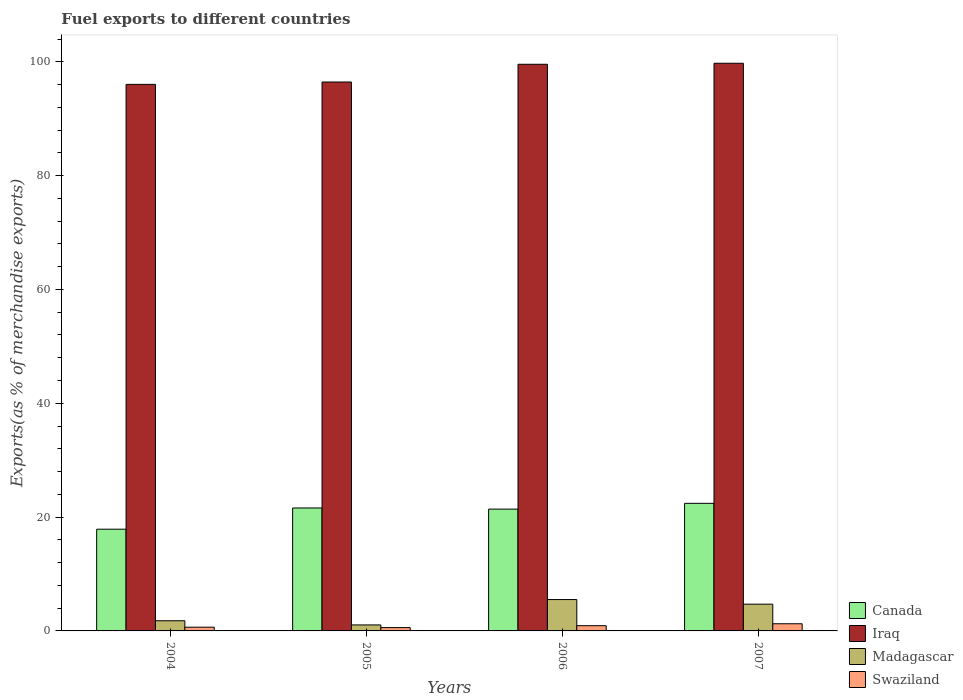How many different coloured bars are there?
Your answer should be very brief. 4. How many groups of bars are there?
Your response must be concise. 4. Are the number of bars per tick equal to the number of legend labels?
Give a very brief answer. Yes. What is the label of the 2nd group of bars from the left?
Offer a very short reply. 2005. In how many cases, is the number of bars for a given year not equal to the number of legend labels?
Your response must be concise. 0. What is the percentage of exports to different countries in Swaziland in 2005?
Provide a short and direct response. 0.58. Across all years, what is the maximum percentage of exports to different countries in Madagascar?
Your answer should be compact. 5.51. Across all years, what is the minimum percentage of exports to different countries in Iraq?
Your response must be concise. 96.03. What is the total percentage of exports to different countries in Iraq in the graph?
Ensure brevity in your answer.  391.78. What is the difference between the percentage of exports to different countries in Canada in 2004 and that in 2005?
Give a very brief answer. -3.73. What is the difference between the percentage of exports to different countries in Iraq in 2007 and the percentage of exports to different countries in Swaziland in 2006?
Give a very brief answer. 98.82. What is the average percentage of exports to different countries in Canada per year?
Your answer should be very brief. 20.82. In the year 2007, what is the difference between the percentage of exports to different countries in Iraq and percentage of exports to different countries in Canada?
Give a very brief answer. 77.32. What is the ratio of the percentage of exports to different countries in Iraq in 2004 to that in 2006?
Offer a very short reply. 0.96. Is the difference between the percentage of exports to different countries in Iraq in 2005 and 2006 greater than the difference between the percentage of exports to different countries in Canada in 2005 and 2006?
Give a very brief answer. No. What is the difference between the highest and the second highest percentage of exports to different countries in Madagascar?
Keep it short and to the point. 0.81. What is the difference between the highest and the lowest percentage of exports to different countries in Canada?
Offer a terse response. 4.54. In how many years, is the percentage of exports to different countries in Canada greater than the average percentage of exports to different countries in Canada taken over all years?
Offer a very short reply. 3. Is it the case that in every year, the sum of the percentage of exports to different countries in Madagascar and percentage of exports to different countries in Swaziland is greater than the sum of percentage of exports to different countries in Canada and percentage of exports to different countries in Iraq?
Give a very brief answer. No. What does the 1st bar from the left in 2006 represents?
Your answer should be very brief. Canada. What does the 4th bar from the right in 2004 represents?
Give a very brief answer. Canada. How many bars are there?
Keep it short and to the point. 16. Are all the bars in the graph horizontal?
Your answer should be compact. No. How many years are there in the graph?
Offer a terse response. 4. What is the difference between two consecutive major ticks on the Y-axis?
Keep it short and to the point. 20. Does the graph contain any zero values?
Offer a very short reply. No. Where does the legend appear in the graph?
Offer a terse response. Bottom right. How are the legend labels stacked?
Your answer should be compact. Vertical. What is the title of the graph?
Your answer should be very brief. Fuel exports to different countries. What is the label or title of the X-axis?
Provide a short and direct response. Years. What is the label or title of the Y-axis?
Ensure brevity in your answer.  Exports(as % of merchandise exports). What is the Exports(as % of merchandise exports) of Canada in 2004?
Offer a terse response. 17.87. What is the Exports(as % of merchandise exports) in Iraq in 2004?
Provide a succinct answer. 96.03. What is the Exports(as % of merchandise exports) of Madagascar in 2004?
Your response must be concise. 1.79. What is the Exports(as % of merchandise exports) of Swaziland in 2004?
Offer a terse response. 0.65. What is the Exports(as % of merchandise exports) of Canada in 2005?
Provide a short and direct response. 21.6. What is the Exports(as % of merchandise exports) in Iraq in 2005?
Provide a succinct answer. 96.45. What is the Exports(as % of merchandise exports) in Madagascar in 2005?
Offer a very short reply. 1.05. What is the Exports(as % of merchandise exports) of Swaziland in 2005?
Offer a terse response. 0.58. What is the Exports(as % of merchandise exports) of Canada in 2006?
Your answer should be very brief. 21.4. What is the Exports(as % of merchandise exports) of Iraq in 2006?
Make the answer very short. 99.56. What is the Exports(as % of merchandise exports) in Madagascar in 2006?
Provide a short and direct response. 5.51. What is the Exports(as % of merchandise exports) in Swaziland in 2006?
Offer a very short reply. 0.92. What is the Exports(as % of merchandise exports) in Canada in 2007?
Your response must be concise. 22.42. What is the Exports(as % of merchandise exports) in Iraq in 2007?
Your response must be concise. 99.74. What is the Exports(as % of merchandise exports) of Madagascar in 2007?
Keep it short and to the point. 4.7. What is the Exports(as % of merchandise exports) in Swaziland in 2007?
Ensure brevity in your answer.  1.26. Across all years, what is the maximum Exports(as % of merchandise exports) of Canada?
Your answer should be compact. 22.42. Across all years, what is the maximum Exports(as % of merchandise exports) in Iraq?
Ensure brevity in your answer.  99.74. Across all years, what is the maximum Exports(as % of merchandise exports) in Madagascar?
Offer a very short reply. 5.51. Across all years, what is the maximum Exports(as % of merchandise exports) in Swaziland?
Your response must be concise. 1.26. Across all years, what is the minimum Exports(as % of merchandise exports) in Canada?
Keep it short and to the point. 17.87. Across all years, what is the minimum Exports(as % of merchandise exports) of Iraq?
Provide a short and direct response. 96.03. Across all years, what is the minimum Exports(as % of merchandise exports) of Madagascar?
Your response must be concise. 1.05. Across all years, what is the minimum Exports(as % of merchandise exports) of Swaziland?
Keep it short and to the point. 0.58. What is the total Exports(as % of merchandise exports) of Canada in the graph?
Your response must be concise. 83.29. What is the total Exports(as % of merchandise exports) of Iraq in the graph?
Make the answer very short. 391.78. What is the total Exports(as % of merchandise exports) in Madagascar in the graph?
Ensure brevity in your answer.  13.05. What is the total Exports(as % of merchandise exports) of Swaziland in the graph?
Make the answer very short. 3.41. What is the difference between the Exports(as % of merchandise exports) in Canada in 2004 and that in 2005?
Give a very brief answer. -3.73. What is the difference between the Exports(as % of merchandise exports) of Iraq in 2004 and that in 2005?
Keep it short and to the point. -0.41. What is the difference between the Exports(as % of merchandise exports) of Madagascar in 2004 and that in 2005?
Provide a succinct answer. 0.73. What is the difference between the Exports(as % of merchandise exports) of Swaziland in 2004 and that in 2005?
Provide a short and direct response. 0.07. What is the difference between the Exports(as % of merchandise exports) of Canada in 2004 and that in 2006?
Ensure brevity in your answer.  -3.53. What is the difference between the Exports(as % of merchandise exports) in Iraq in 2004 and that in 2006?
Make the answer very short. -3.53. What is the difference between the Exports(as % of merchandise exports) of Madagascar in 2004 and that in 2006?
Keep it short and to the point. -3.72. What is the difference between the Exports(as % of merchandise exports) in Swaziland in 2004 and that in 2006?
Provide a short and direct response. -0.27. What is the difference between the Exports(as % of merchandise exports) of Canada in 2004 and that in 2007?
Your response must be concise. -4.54. What is the difference between the Exports(as % of merchandise exports) of Iraq in 2004 and that in 2007?
Make the answer very short. -3.71. What is the difference between the Exports(as % of merchandise exports) of Madagascar in 2004 and that in 2007?
Offer a terse response. -2.92. What is the difference between the Exports(as % of merchandise exports) of Swaziland in 2004 and that in 2007?
Offer a very short reply. -0.6. What is the difference between the Exports(as % of merchandise exports) of Canada in 2005 and that in 2006?
Provide a short and direct response. 0.2. What is the difference between the Exports(as % of merchandise exports) in Iraq in 2005 and that in 2006?
Offer a terse response. -3.12. What is the difference between the Exports(as % of merchandise exports) in Madagascar in 2005 and that in 2006?
Ensure brevity in your answer.  -4.46. What is the difference between the Exports(as % of merchandise exports) in Swaziland in 2005 and that in 2006?
Make the answer very short. -0.34. What is the difference between the Exports(as % of merchandise exports) of Canada in 2005 and that in 2007?
Provide a succinct answer. -0.82. What is the difference between the Exports(as % of merchandise exports) in Iraq in 2005 and that in 2007?
Provide a succinct answer. -3.29. What is the difference between the Exports(as % of merchandise exports) of Madagascar in 2005 and that in 2007?
Your answer should be very brief. -3.65. What is the difference between the Exports(as % of merchandise exports) of Swaziland in 2005 and that in 2007?
Ensure brevity in your answer.  -0.68. What is the difference between the Exports(as % of merchandise exports) in Canada in 2006 and that in 2007?
Provide a succinct answer. -1.02. What is the difference between the Exports(as % of merchandise exports) of Iraq in 2006 and that in 2007?
Offer a very short reply. -0.18. What is the difference between the Exports(as % of merchandise exports) of Madagascar in 2006 and that in 2007?
Make the answer very short. 0.81. What is the difference between the Exports(as % of merchandise exports) in Swaziland in 2006 and that in 2007?
Your answer should be very brief. -0.34. What is the difference between the Exports(as % of merchandise exports) of Canada in 2004 and the Exports(as % of merchandise exports) of Iraq in 2005?
Your answer should be very brief. -78.57. What is the difference between the Exports(as % of merchandise exports) of Canada in 2004 and the Exports(as % of merchandise exports) of Madagascar in 2005?
Your answer should be very brief. 16.82. What is the difference between the Exports(as % of merchandise exports) of Canada in 2004 and the Exports(as % of merchandise exports) of Swaziland in 2005?
Ensure brevity in your answer.  17.29. What is the difference between the Exports(as % of merchandise exports) in Iraq in 2004 and the Exports(as % of merchandise exports) in Madagascar in 2005?
Offer a terse response. 94.98. What is the difference between the Exports(as % of merchandise exports) of Iraq in 2004 and the Exports(as % of merchandise exports) of Swaziland in 2005?
Provide a short and direct response. 95.45. What is the difference between the Exports(as % of merchandise exports) of Madagascar in 2004 and the Exports(as % of merchandise exports) of Swaziland in 2005?
Your answer should be compact. 1.2. What is the difference between the Exports(as % of merchandise exports) of Canada in 2004 and the Exports(as % of merchandise exports) of Iraq in 2006?
Give a very brief answer. -81.69. What is the difference between the Exports(as % of merchandise exports) in Canada in 2004 and the Exports(as % of merchandise exports) in Madagascar in 2006?
Provide a succinct answer. 12.36. What is the difference between the Exports(as % of merchandise exports) in Canada in 2004 and the Exports(as % of merchandise exports) in Swaziland in 2006?
Keep it short and to the point. 16.96. What is the difference between the Exports(as % of merchandise exports) in Iraq in 2004 and the Exports(as % of merchandise exports) in Madagascar in 2006?
Give a very brief answer. 90.52. What is the difference between the Exports(as % of merchandise exports) in Iraq in 2004 and the Exports(as % of merchandise exports) in Swaziland in 2006?
Give a very brief answer. 95.11. What is the difference between the Exports(as % of merchandise exports) of Madagascar in 2004 and the Exports(as % of merchandise exports) of Swaziland in 2006?
Your response must be concise. 0.87. What is the difference between the Exports(as % of merchandise exports) of Canada in 2004 and the Exports(as % of merchandise exports) of Iraq in 2007?
Your answer should be very brief. -81.86. What is the difference between the Exports(as % of merchandise exports) of Canada in 2004 and the Exports(as % of merchandise exports) of Madagascar in 2007?
Provide a succinct answer. 13.17. What is the difference between the Exports(as % of merchandise exports) in Canada in 2004 and the Exports(as % of merchandise exports) in Swaziland in 2007?
Your answer should be very brief. 16.62. What is the difference between the Exports(as % of merchandise exports) in Iraq in 2004 and the Exports(as % of merchandise exports) in Madagascar in 2007?
Offer a terse response. 91.33. What is the difference between the Exports(as % of merchandise exports) in Iraq in 2004 and the Exports(as % of merchandise exports) in Swaziland in 2007?
Ensure brevity in your answer.  94.77. What is the difference between the Exports(as % of merchandise exports) in Madagascar in 2004 and the Exports(as % of merchandise exports) in Swaziland in 2007?
Provide a short and direct response. 0.53. What is the difference between the Exports(as % of merchandise exports) of Canada in 2005 and the Exports(as % of merchandise exports) of Iraq in 2006?
Provide a short and direct response. -77.96. What is the difference between the Exports(as % of merchandise exports) of Canada in 2005 and the Exports(as % of merchandise exports) of Madagascar in 2006?
Your response must be concise. 16.09. What is the difference between the Exports(as % of merchandise exports) in Canada in 2005 and the Exports(as % of merchandise exports) in Swaziland in 2006?
Offer a very short reply. 20.68. What is the difference between the Exports(as % of merchandise exports) of Iraq in 2005 and the Exports(as % of merchandise exports) of Madagascar in 2006?
Your answer should be very brief. 90.94. What is the difference between the Exports(as % of merchandise exports) of Iraq in 2005 and the Exports(as % of merchandise exports) of Swaziland in 2006?
Offer a terse response. 95.53. What is the difference between the Exports(as % of merchandise exports) of Madagascar in 2005 and the Exports(as % of merchandise exports) of Swaziland in 2006?
Provide a succinct answer. 0.13. What is the difference between the Exports(as % of merchandise exports) of Canada in 2005 and the Exports(as % of merchandise exports) of Iraq in 2007?
Your answer should be very brief. -78.14. What is the difference between the Exports(as % of merchandise exports) in Canada in 2005 and the Exports(as % of merchandise exports) in Madagascar in 2007?
Your answer should be very brief. 16.9. What is the difference between the Exports(as % of merchandise exports) of Canada in 2005 and the Exports(as % of merchandise exports) of Swaziland in 2007?
Provide a short and direct response. 20.34. What is the difference between the Exports(as % of merchandise exports) of Iraq in 2005 and the Exports(as % of merchandise exports) of Madagascar in 2007?
Your response must be concise. 91.74. What is the difference between the Exports(as % of merchandise exports) in Iraq in 2005 and the Exports(as % of merchandise exports) in Swaziland in 2007?
Your answer should be compact. 95.19. What is the difference between the Exports(as % of merchandise exports) of Madagascar in 2005 and the Exports(as % of merchandise exports) of Swaziland in 2007?
Offer a terse response. -0.2. What is the difference between the Exports(as % of merchandise exports) of Canada in 2006 and the Exports(as % of merchandise exports) of Iraq in 2007?
Offer a terse response. -78.34. What is the difference between the Exports(as % of merchandise exports) of Canada in 2006 and the Exports(as % of merchandise exports) of Madagascar in 2007?
Offer a terse response. 16.7. What is the difference between the Exports(as % of merchandise exports) of Canada in 2006 and the Exports(as % of merchandise exports) of Swaziland in 2007?
Keep it short and to the point. 20.14. What is the difference between the Exports(as % of merchandise exports) in Iraq in 2006 and the Exports(as % of merchandise exports) in Madagascar in 2007?
Your answer should be very brief. 94.86. What is the difference between the Exports(as % of merchandise exports) of Iraq in 2006 and the Exports(as % of merchandise exports) of Swaziland in 2007?
Make the answer very short. 98.3. What is the difference between the Exports(as % of merchandise exports) in Madagascar in 2006 and the Exports(as % of merchandise exports) in Swaziland in 2007?
Provide a succinct answer. 4.25. What is the average Exports(as % of merchandise exports) of Canada per year?
Keep it short and to the point. 20.82. What is the average Exports(as % of merchandise exports) of Iraq per year?
Give a very brief answer. 97.94. What is the average Exports(as % of merchandise exports) in Madagascar per year?
Give a very brief answer. 3.26. What is the average Exports(as % of merchandise exports) of Swaziland per year?
Your answer should be compact. 0.85. In the year 2004, what is the difference between the Exports(as % of merchandise exports) in Canada and Exports(as % of merchandise exports) in Iraq?
Offer a very short reply. -78.16. In the year 2004, what is the difference between the Exports(as % of merchandise exports) in Canada and Exports(as % of merchandise exports) in Madagascar?
Your answer should be very brief. 16.09. In the year 2004, what is the difference between the Exports(as % of merchandise exports) of Canada and Exports(as % of merchandise exports) of Swaziland?
Offer a very short reply. 17.22. In the year 2004, what is the difference between the Exports(as % of merchandise exports) in Iraq and Exports(as % of merchandise exports) in Madagascar?
Provide a succinct answer. 94.25. In the year 2004, what is the difference between the Exports(as % of merchandise exports) of Iraq and Exports(as % of merchandise exports) of Swaziland?
Your response must be concise. 95.38. In the year 2004, what is the difference between the Exports(as % of merchandise exports) of Madagascar and Exports(as % of merchandise exports) of Swaziland?
Offer a very short reply. 1.13. In the year 2005, what is the difference between the Exports(as % of merchandise exports) of Canada and Exports(as % of merchandise exports) of Iraq?
Keep it short and to the point. -74.84. In the year 2005, what is the difference between the Exports(as % of merchandise exports) in Canada and Exports(as % of merchandise exports) in Madagascar?
Keep it short and to the point. 20.55. In the year 2005, what is the difference between the Exports(as % of merchandise exports) in Canada and Exports(as % of merchandise exports) in Swaziland?
Keep it short and to the point. 21.02. In the year 2005, what is the difference between the Exports(as % of merchandise exports) in Iraq and Exports(as % of merchandise exports) in Madagascar?
Ensure brevity in your answer.  95.39. In the year 2005, what is the difference between the Exports(as % of merchandise exports) of Iraq and Exports(as % of merchandise exports) of Swaziland?
Offer a terse response. 95.86. In the year 2005, what is the difference between the Exports(as % of merchandise exports) in Madagascar and Exports(as % of merchandise exports) in Swaziland?
Offer a terse response. 0.47. In the year 2006, what is the difference between the Exports(as % of merchandise exports) of Canada and Exports(as % of merchandise exports) of Iraq?
Your answer should be compact. -78.16. In the year 2006, what is the difference between the Exports(as % of merchandise exports) of Canada and Exports(as % of merchandise exports) of Madagascar?
Provide a succinct answer. 15.89. In the year 2006, what is the difference between the Exports(as % of merchandise exports) in Canada and Exports(as % of merchandise exports) in Swaziland?
Offer a terse response. 20.48. In the year 2006, what is the difference between the Exports(as % of merchandise exports) in Iraq and Exports(as % of merchandise exports) in Madagascar?
Make the answer very short. 94.05. In the year 2006, what is the difference between the Exports(as % of merchandise exports) of Iraq and Exports(as % of merchandise exports) of Swaziland?
Offer a terse response. 98.64. In the year 2006, what is the difference between the Exports(as % of merchandise exports) of Madagascar and Exports(as % of merchandise exports) of Swaziland?
Give a very brief answer. 4.59. In the year 2007, what is the difference between the Exports(as % of merchandise exports) in Canada and Exports(as % of merchandise exports) in Iraq?
Your response must be concise. -77.32. In the year 2007, what is the difference between the Exports(as % of merchandise exports) in Canada and Exports(as % of merchandise exports) in Madagascar?
Provide a succinct answer. 17.72. In the year 2007, what is the difference between the Exports(as % of merchandise exports) of Canada and Exports(as % of merchandise exports) of Swaziland?
Your answer should be compact. 21.16. In the year 2007, what is the difference between the Exports(as % of merchandise exports) in Iraq and Exports(as % of merchandise exports) in Madagascar?
Give a very brief answer. 95.04. In the year 2007, what is the difference between the Exports(as % of merchandise exports) in Iraq and Exports(as % of merchandise exports) in Swaziland?
Give a very brief answer. 98.48. In the year 2007, what is the difference between the Exports(as % of merchandise exports) in Madagascar and Exports(as % of merchandise exports) in Swaziland?
Your response must be concise. 3.44. What is the ratio of the Exports(as % of merchandise exports) in Canada in 2004 to that in 2005?
Make the answer very short. 0.83. What is the ratio of the Exports(as % of merchandise exports) in Iraq in 2004 to that in 2005?
Provide a short and direct response. 1. What is the ratio of the Exports(as % of merchandise exports) in Madagascar in 2004 to that in 2005?
Offer a terse response. 1.69. What is the ratio of the Exports(as % of merchandise exports) in Swaziland in 2004 to that in 2005?
Your answer should be compact. 1.12. What is the ratio of the Exports(as % of merchandise exports) of Canada in 2004 to that in 2006?
Provide a short and direct response. 0.84. What is the ratio of the Exports(as % of merchandise exports) in Iraq in 2004 to that in 2006?
Your response must be concise. 0.96. What is the ratio of the Exports(as % of merchandise exports) of Madagascar in 2004 to that in 2006?
Your response must be concise. 0.32. What is the ratio of the Exports(as % of merchandise exports) in Swaziland in 2004 to that in 2006?
Keep it short and to the point. 0.71. What is the ratio of the Exports(as % of merchandise exports) of Canada in 2004 to that in 2007?
Your answer should be compact. 0.8. What is the ratio of the Exports(as % of merchandise exports) of Iraq in 2004 to that in 2007?
Make the answer very short. 0.96. What is the ratio of the Exports(as % of merchandise exports) of Madagascar in 2004 to that in 2007?
Offer a terse response. 0.38. What is the ratio of the Exports(as % of merchandise exports) in Swaziland in 2004 to that in 2007?
Your response must be concise. 0.52. What is the ratio of the Exports(as % of merchandise exports) in Canada in 2005 to that in 2006?
Ensure brevity in your answer.  1.01. What is the ratio of the Exports(as % of merchandise exports) in Iraq in 2005 to that in 2006?
Your answer should be very brief. 0.97. What is the ratio of the Exports(as % of merchandise exports) in Madagascar in 2005 to that in 2006?
Ensure brevity in your answer.  0.19. What is the ratio of the Exports(as % of merchandise exports) of Swaziland in 2005 to that in 2006?
Provide a succinct answer. 0.63. What is the ratio of the Exports(as % of merchandise exports) of Canada in 2005 to that in 2007?
Provide a succinct answer. 0.96. What is the ratio of the Exports(as % of merchandise exports) of Iraq in 2005 to that in 2007?
Your response must be concise. 0.97. What is the ratio of the Exports(as % of merchandise exports) in Madagascar in 2005 to that in 2007?
Provide a succinct answer. 0.22. What is the ratio of the Exports(as % of merchandise exports) in Swaziland in 2005 to that in 2007?
Provide a short and direct response. 0.46. What is the ratio of the Exports(as % of merchandise exports) in Canada in 2006 to that in 2007?
Provide a short and direct response. 0.95. What is the ratio of the Exports(as % of merchandise exports) of Iraq in 2006 to that in 2007?
Make the answer very short. 1. What is the ratio of the Exports(as % of merchandise exports) of Madagascar in 2006 to that in 2007?
Your answer should be very brief. 1.17. What is the ratio of the Exports(as % of merchandise exports) of Swaziland in 2006 to that in 2007?
Your answer should be compact. 0.73. What is the difference between the highest and the second highest Exports(as % of merchandise exports) in Canada?
Ensure brevity in your answer.  0.82. What is the difference between the highest and the second highest Exports(as % of merchandise exports) of Iraq?
Your answer should be compact. 0.18. What is the difference between the highest and the second highest Exports(as % of merchandise exports) in Madagascar?
Your answer should be compact. 0.81. What is the difference between the highest and the second highest Exports(as % of merchandise exports) of Swaziland?
Your answer should be compact. 0.34. What is the difference between the highest and the lowest Exports(as % of merchandise exports) in Canada?
Give a very brief answer. 4.54. What is the difference between the highest and the lowest Exports(as % of merchandise exports) of Iraq?
Your response must be concise. 3.71. What is the difference between the highest and the lowest Exports(as % of merchandise exports) in Madagascar?
Give a very brief answer. 4.46. What is the difference between the highest and the lowest Exports(as % of merchandise exports) in Swaziland?
Your answer should be very brief. 0.68. 